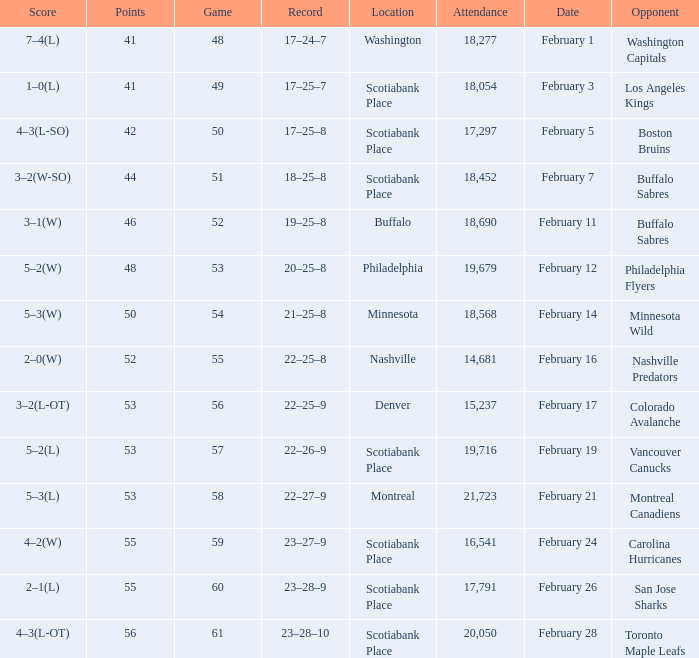Could you parse the entire table? {'header': ['Score', 'Points', 'Game', 'Record', 'Location', 'Attendance', 'Date', 'Opponent'], 'rows': [['7–4(L)', '41', '48', '17–24–7', 'Washington', '18,277', 'February 1', 'Washington Capitals'], ['1–0(L)', '41', '49', '17–25–7', 'Scotiabank Place', '18,054', 'February 3', 'Los Angeles Kings'], ['4–3(L-SO)', '42', '50', '17–25–8', 'Scotiabank Place', '17,297', 'February 5', 'Boston Bruins'], ['3–2(W-SO)', '44', '51', '18–25–8', 'Scotiabank Place', '18,452', 'February 7', 'Buffalo Sabres'], ['3–1(W)', '46', '52', '19–25–8', 'Buffalo', '18,690', 'February 11', 'Buffalo Sabres'], ['5–2(W)', '48', '53', '20–25–8', 'Philadelphia', '19,679', 'February 12', 'Philadelphia Flyers'], ['5–3(W)', '50', '54', '21–25–8', 'Minnesota', '18,568', 'February 14', 'Minnesota Wild'], ['2–0(W)', '52', '55', '22–25–8', 'Nashville', '14,681', 'February 16', 'Nashville Predators'], ['3–2(L-OT)', '53', '56', '22–25–9', 'Denver', '15,237', 'February 17', 'Colorado Avalanche'], ['5–2(L)', '53', '57', '22–26–9', 'Scotiabank Place', '19,716', 'February 19', 'Vancouver Canucks'], ['5–3(L)', '53', '58', '22–27–9', 'Montreal', '21,723', 'February 21', 'Montreal Canadiens'], ['4–2(W)', '55', '59', '23–27–9', 'Scotiabank Place', '16,541', 'February 24', 'Carolina Hurricanes'], ['2–1(L)', '55', '60', '23–28–9', 'Scotiabank Place', '17,791', 'February 26', 'San Jose Sharks'], ['4–3(L-OT)', '56', '61', '23–28–10', 'Scotiabank Place', '20,050', 'February 28', 'Toronto Maple Leafs']]} What average game was held on february 24 and has an attendance smaller than 16,541? None. 